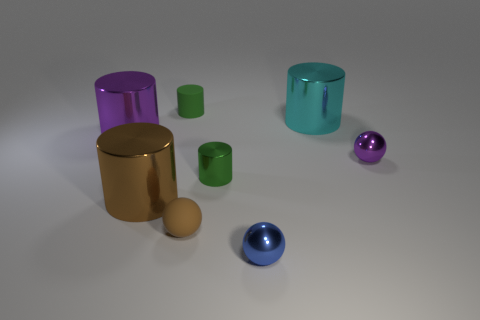Subtract all brown spheres. How many spheres are left? 2 Add 1 tiny metallic balls. How many objects exist? 9 Subtract all brown cylinders. How many cylinders are left? 4 Subtract all cylinders. How many objects are left? 3 Subtract 1 cylinders. How many cylinders are left? 4 Subtract all green cylinders. How many purple balls are left? 1 Subtract all large purple matte objects. Subtract all shiny cylinders. How many objects are left? 4 Add 1 big brown cylinders. How many big brown cylinders are left? 2 Add 6 metal cylinders. How many metal cylinders exist? 10 Subtract 0 brown blocks. How many objects are left? 8 